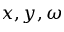Convert formula to latex. <formula><loc_0><loc_0><loc_500><loc_500>x , y , \omega</formula> 